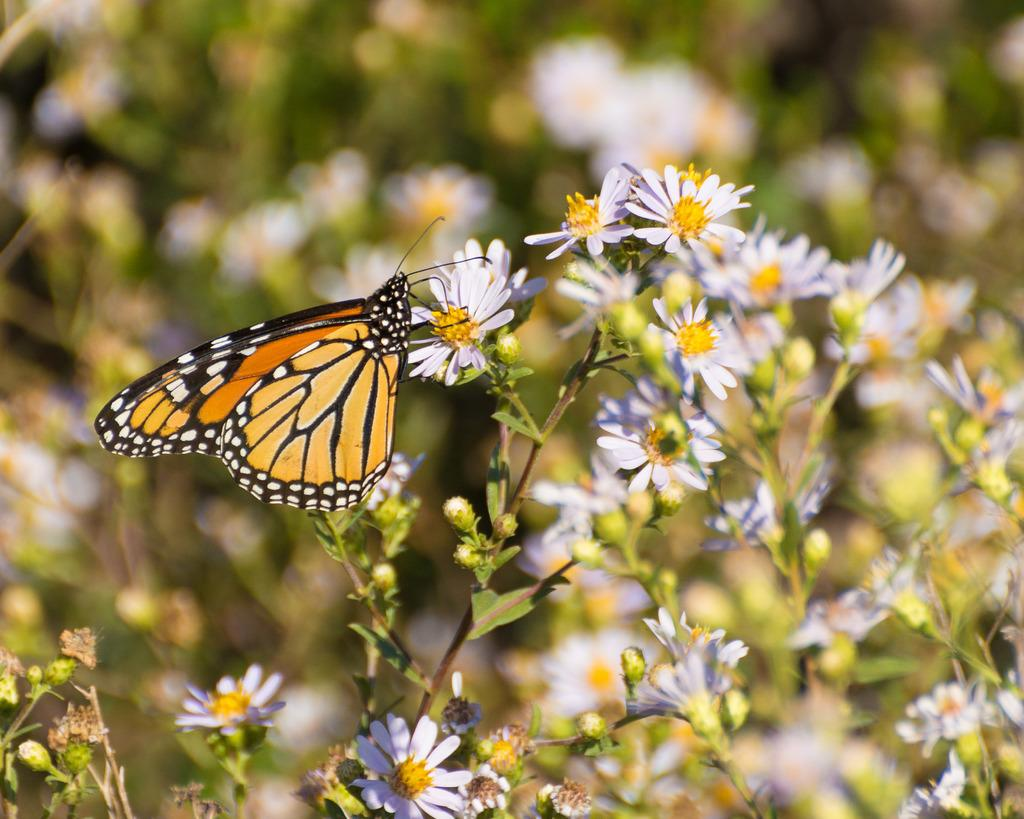What is on the flowers in the image? There is a butterfly on the flowers in the image. What can be seen in the background of the image? Flowers, leaves, and stems are visible in the background of the image. What type of pan is being used by the band in the image? There is no pan or band present in the image; it features a butterfly on flowers with a background of leaves and stems. 